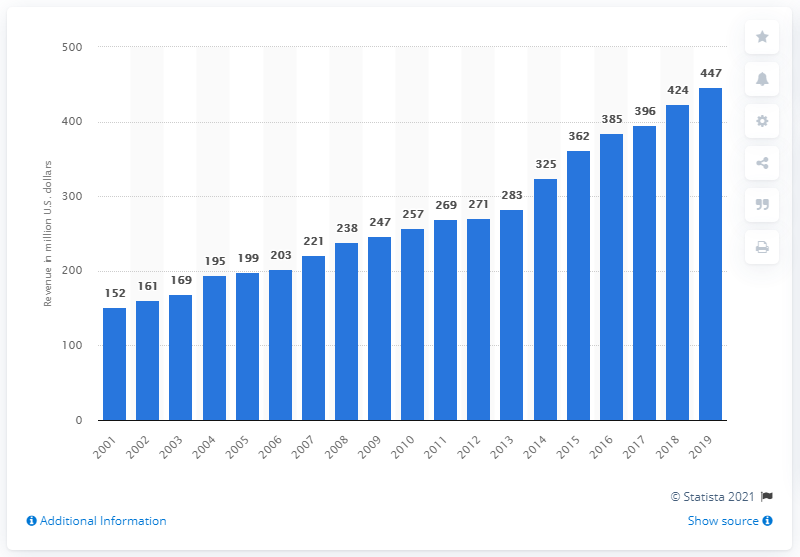Point out several critical features in this image. In 2019, the revenue of the Carolina Panthers was $447 million. 